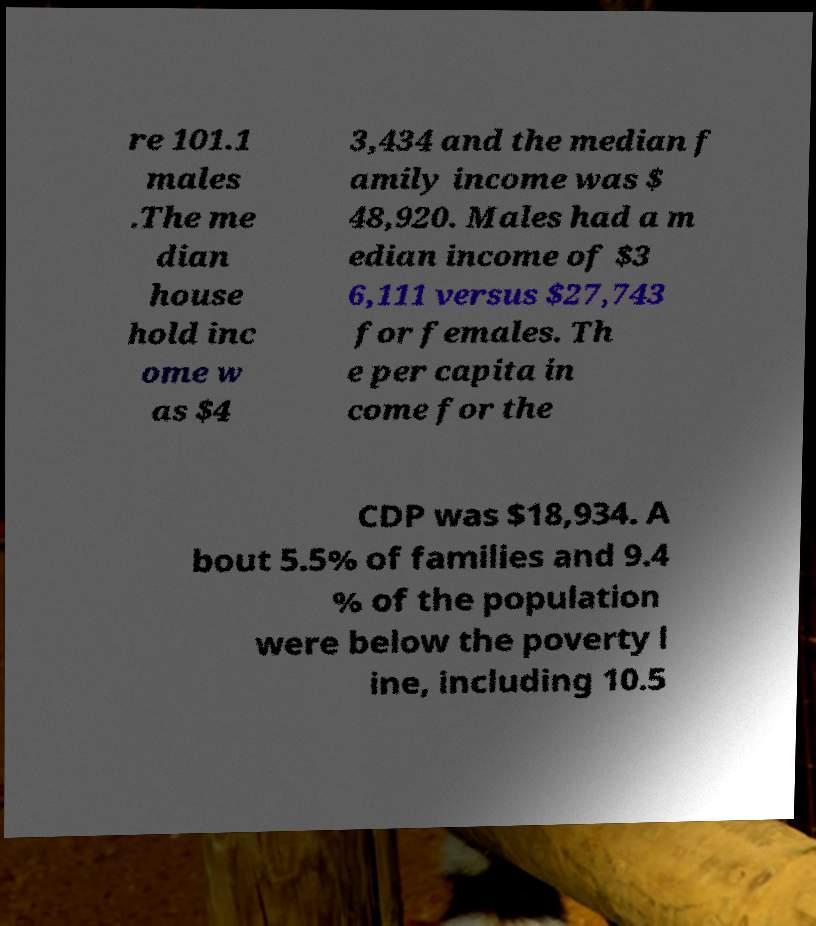Could you assist in decoding the text presented in this image and type it out clearly? re 101.1 males .The me dian house hold inc ome w as $4 3,434 and the median f amily income was $ 48,920. Males had a m edian income of $3 6,111 versus $27,743 for females. Th e per capita in come for the CDP was $18,934. A bout 5.5% of families and 9.4 % of the population were below the poverty l ine, including 10.5 